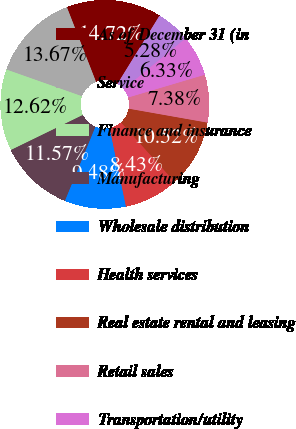Convert chart. <chart><loc_0><loc_0><loc_500><loc_500><pie_chart><fcel>As of December 31 (in<fcel>Service<fcel>Finance and insurance<fcel>Manufacturing<fcel>Wholesale distribution<fcel>Health services<fcel>Real estate rental and leasing<fcel>Retail sales<fcel>Transportation/utility<fcel>Construction<nl><fcel>14.72%<fcel>13.67%<fcel>12.62%<fcel>11.57%<fcel>9.48%<fcel>8.43%<fcel>10.52%<fcel>7.38%<fcel>6.33%<fcel>5.28%<nl></chart> 